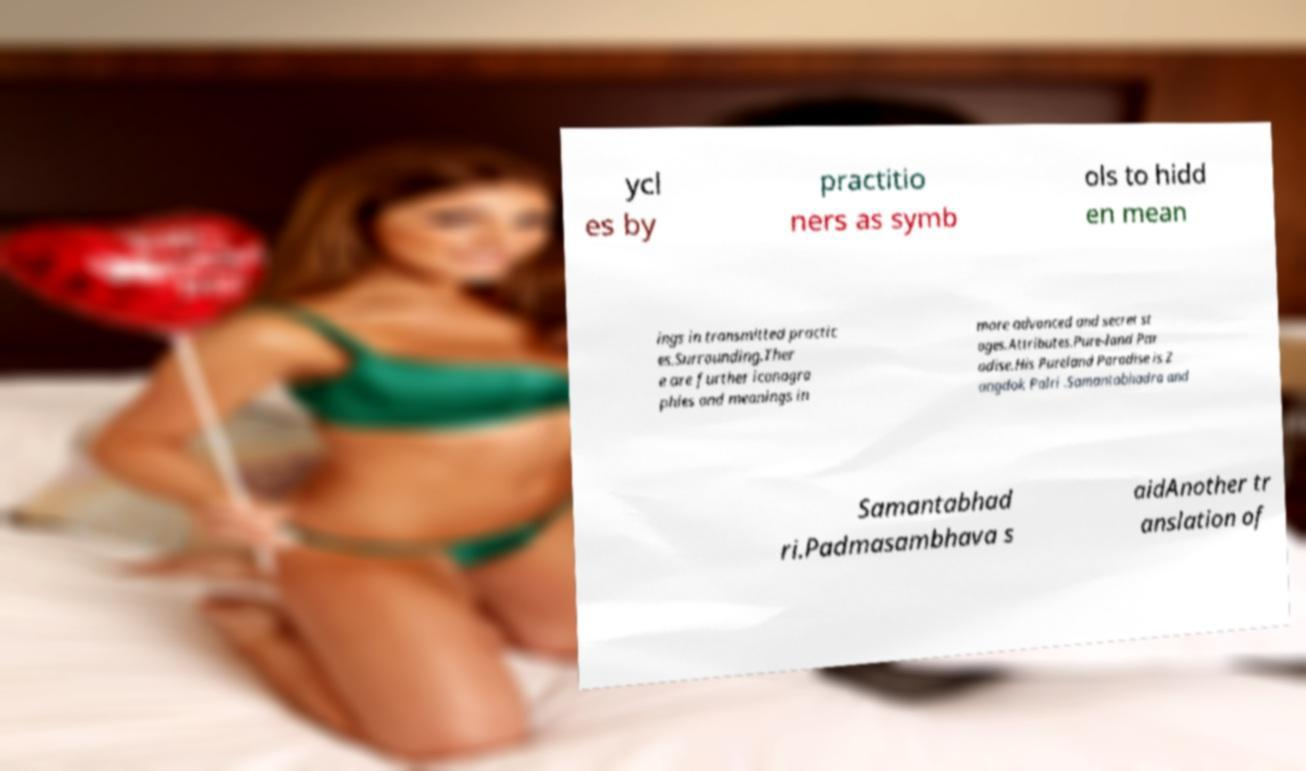Could you assist in decoding the text presented in this image and type it out clearly? ycl es by practitio ners as symb ols to hidd en mean ings in transmitted practic es.Surrounding.Ther e are further iconogra phies and meanings in more advanced and secret st ages.Attributes.Pure-land Par adise.His Pureland Paradise is Z angdok Palri .Samantabhadra and Samantabhad ri.Padmasambhava s aidAnother tr anslation of 